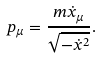Convert formula to latex. <formula><loc_0><loc_0><loc_500><loc_500>p _ { \mu } = \frac { m \dot { x } _ { \mu } } { \sqrt { - \dot { x } ^ { 2 } } } .</formula> 